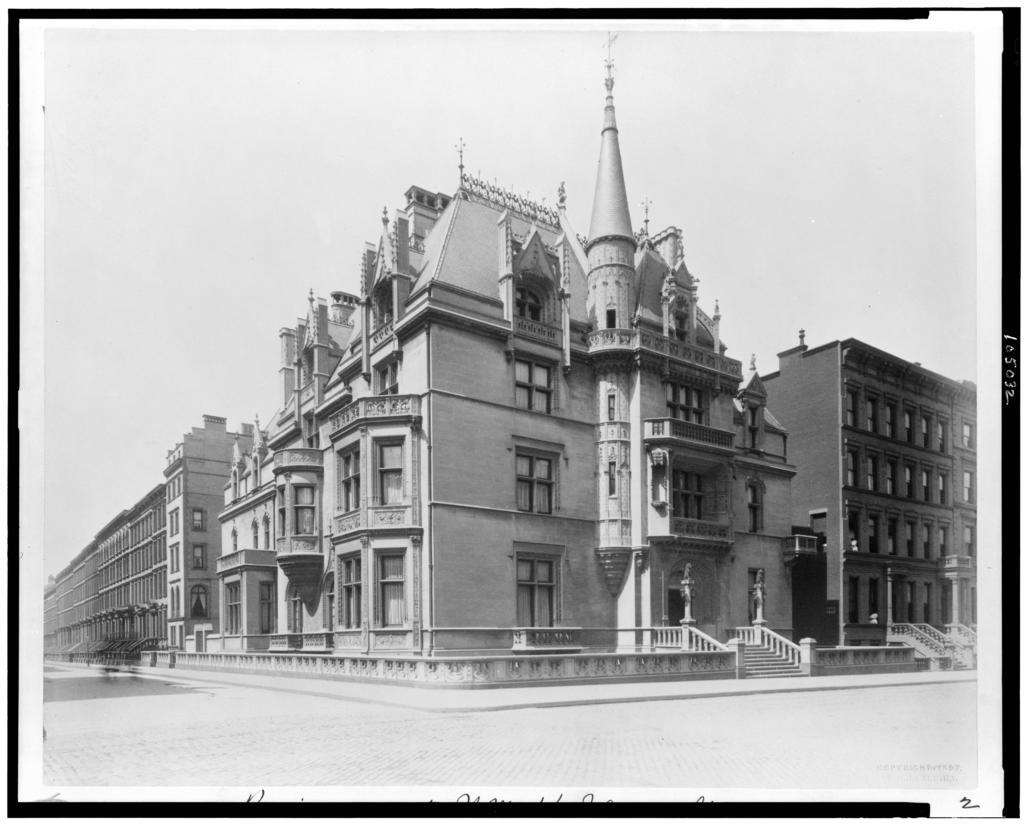What type of structure is visible in the image? There is a building in the image. What is located in front of the building? There is a road in front of the building. What can be seen in the background of the image? The sky is visible in the background of the image. What type of alarm is ringing in the image? There is no alarm present in the image. Is there a judge visible in the image? There is no judge present in the image. 